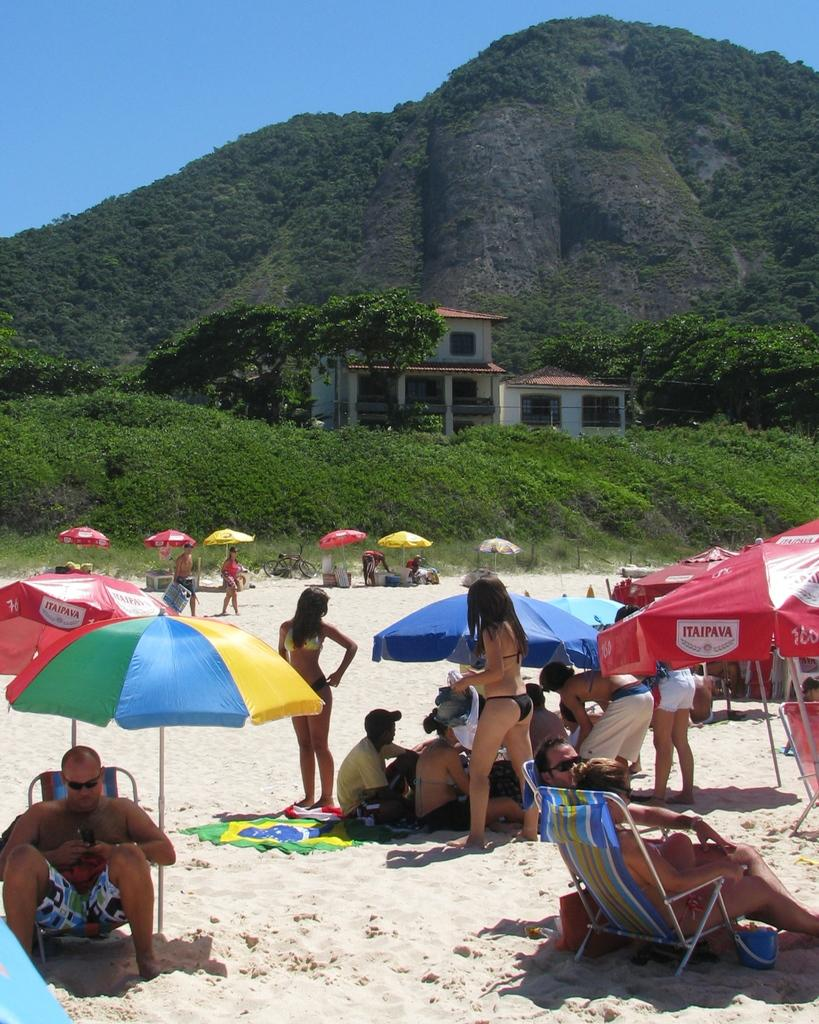What is the setting of the image? The image shows people in the sand, suggesting a beach setting. What objects are present to provide shade for the people? There are umbrellas in the image. What type of seating is available for the people? There are chairs in the image. What structure can be seen in the background? There is a building in the image. What type of vegetation is present in the image? There are trees and plants in the image. What type of landscape can be seen in the distance? There are mountains covered with trees and plants in the image. What part of the sky is visible in the image? The sky is visible in the image. What type of bead is used to decorate the morning attraction in the image? There is no bead or morning attraction present in the image. What type of attraction is the morning event in the image? There is no morning event or attraction present in the image. 